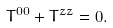Convert formula to latex. <formula><loc_0><loc_0><loc_500><loc_500>T ^ { 0 0 } + T ^ { z z } = 0 .</formula> 